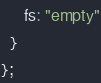<code> <loc_0><loc_0><loc_500><loc_500><_JavaScript_>     fs: "empty"
  }
};
</code> 